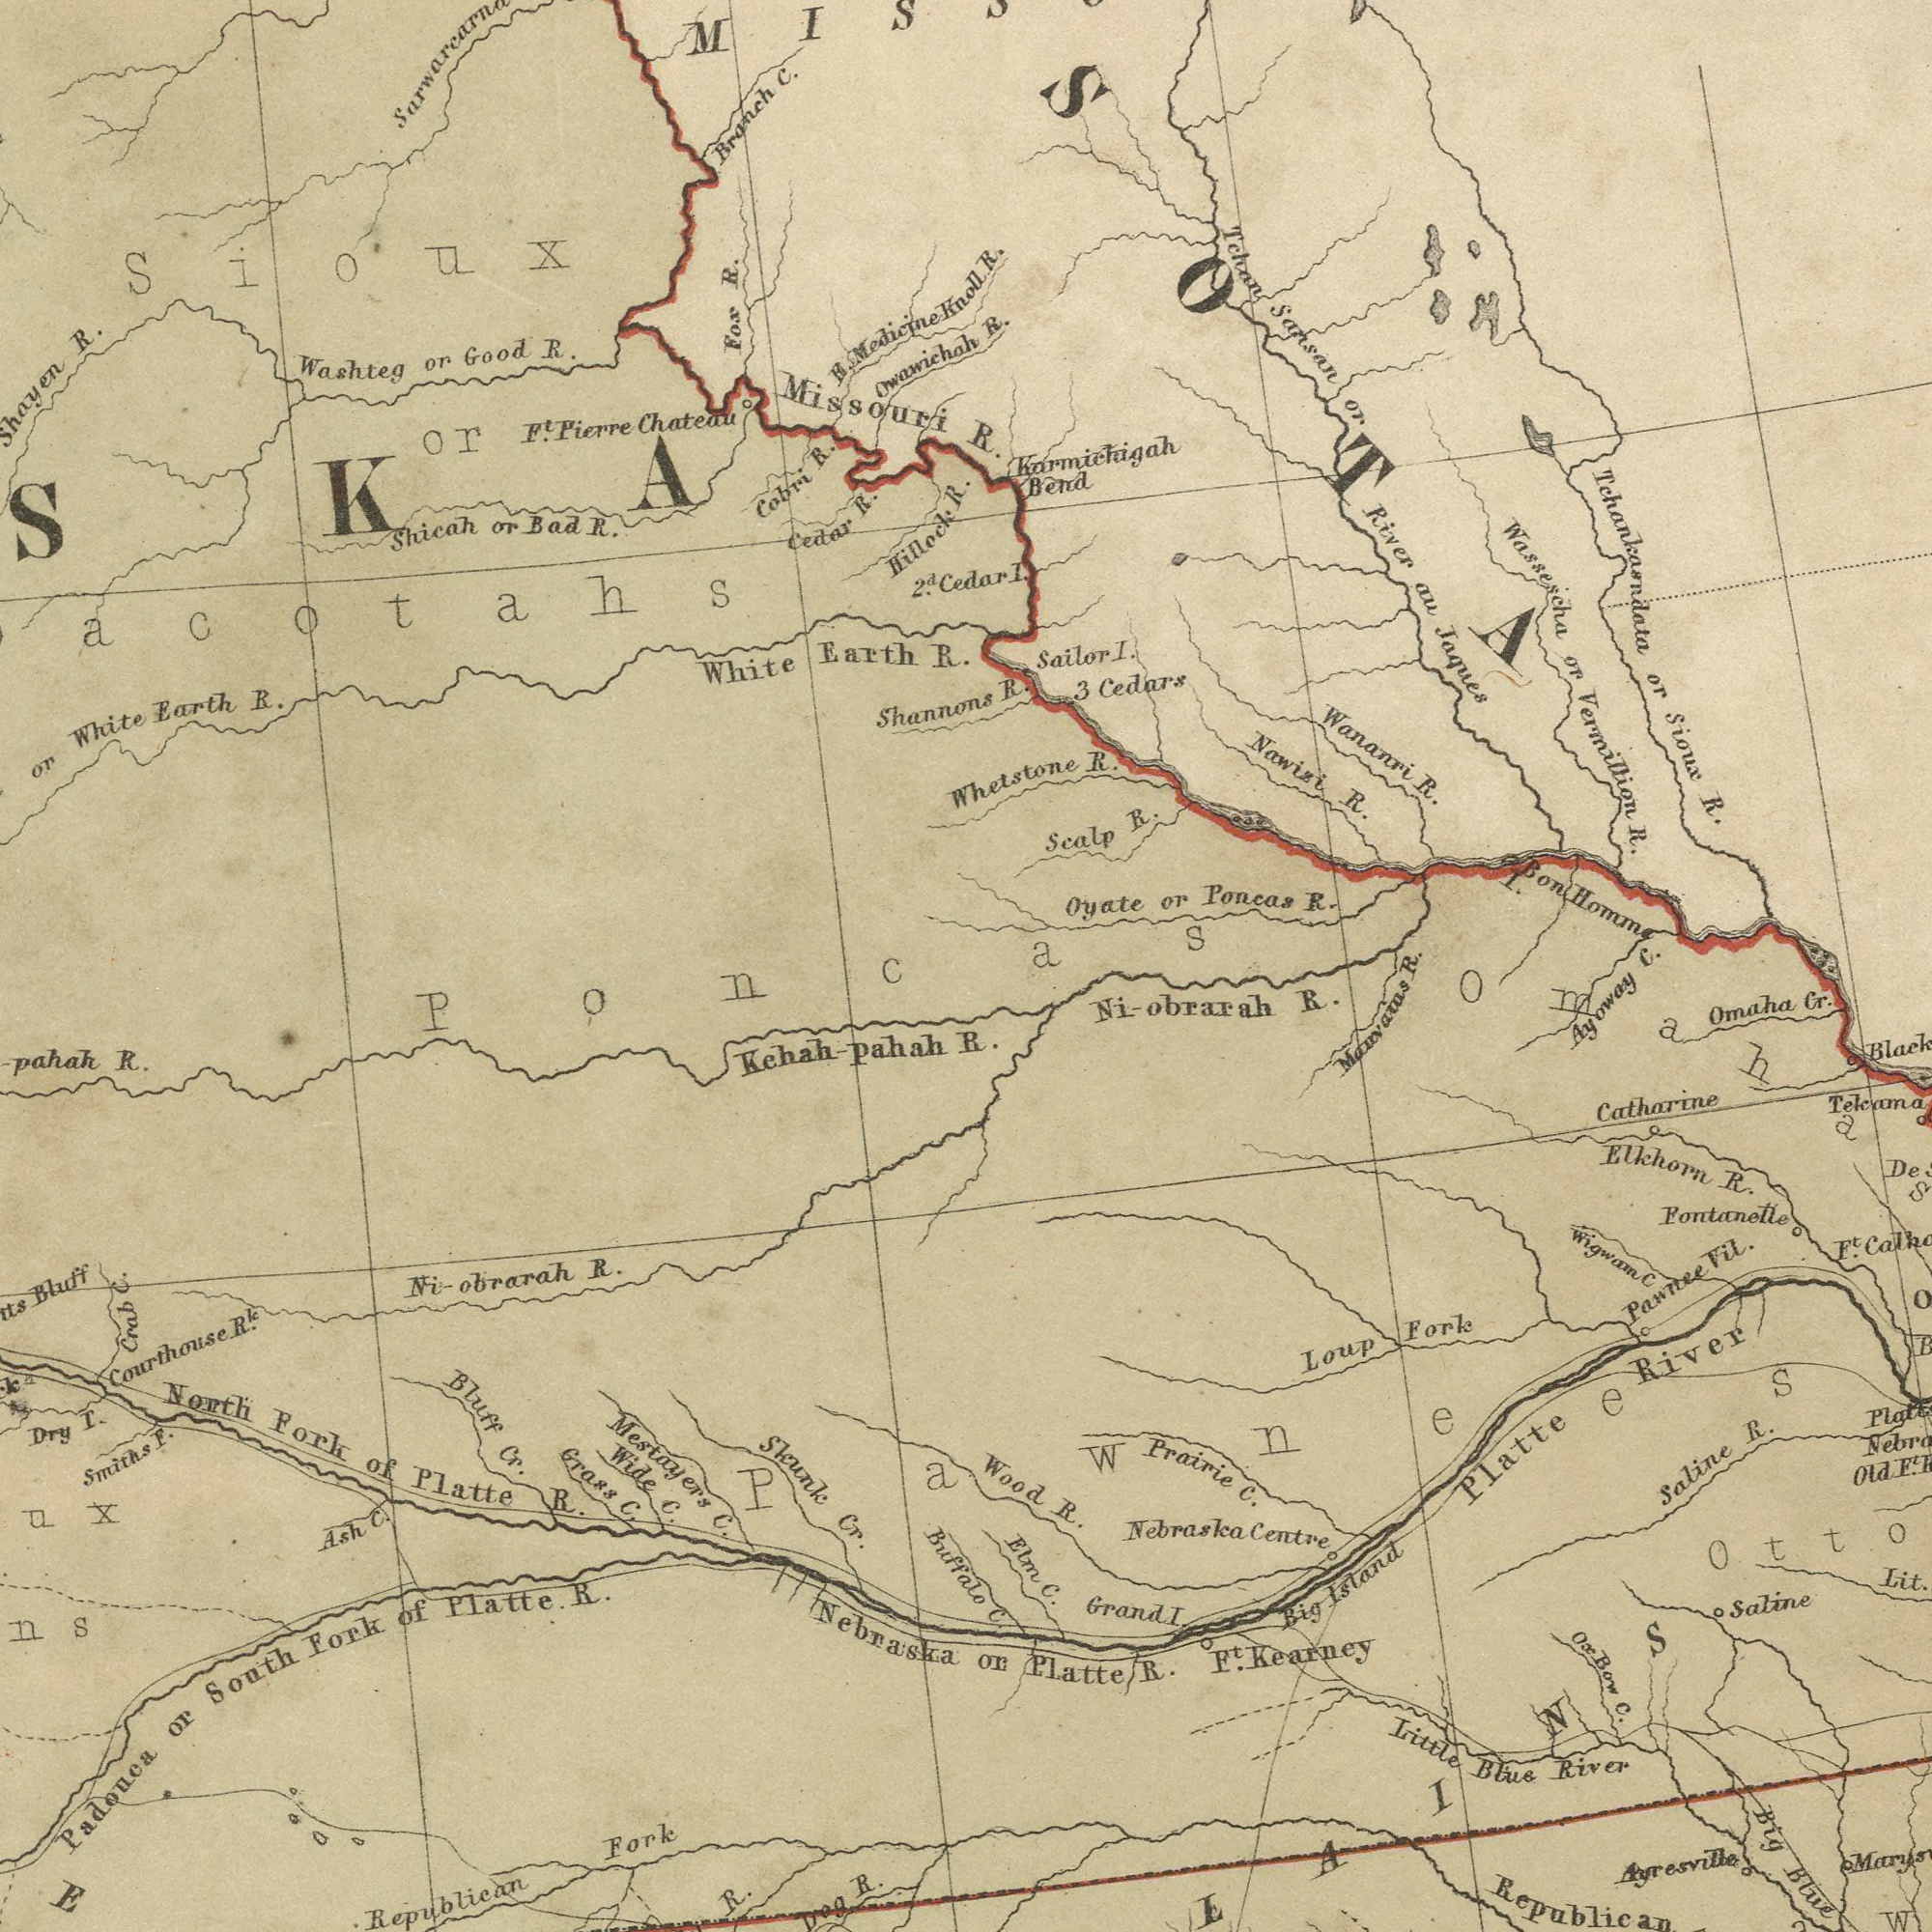What text is visible in the upper-left corner? Missouri Fox R. Branch C. White Earth R. or White Earth R. F.t Pierre Chateau R. Hillock R. Shicah or Bad R. Cedar R. Washteg or Good R. Cobri R. Shannons Sioux or Owawichah R. Medicine Knoll 2d. Cedar PoÌ©ncas What text is shown in the bottom-right quadrant? Manvaius R. or Platte R. C. Pawnees Catharine Fontanetle Ni-obrarah R. Tekama Prairie C. Black Platte River Nebraska Centre Little Blue River Elkhorn R. Omaha Cr. Ft. Kearney Saline R. Big Island Wood R. Saline Ft. Pawnee Vil. Lit. Big Blue Loup Fork Ox Bow C. Elm C. Wigwam C Grand I. Ayresville Republican Ayoway Old F.t What text appears in the top-right area of the image? R. R. R. R. Nawisi R. Tchankasndata or Sioux R. Wananri R. Tchan Sansan or River au Jaques Wassescha or Vermillion R. Oyate or Poncas R. Whetstone R. Sailor I. Scalp R. Cedars Karmichigah Bend I. Bon Homm I. 3 R. C. What text appears in the bottom-left area of the image? Courthouse R.k Mestayers C. R. Skunk Cr. Padouca or South Fork of Platte R. Dry T. Wide C. North Fork of Platte R. Republican Fork Ni_obrarah R. Bluff Bluff Cr. Grass C. Crab C. Smiths F. Dog R. Ash C. Kehah- pahah R. Nebraska Buffalo 